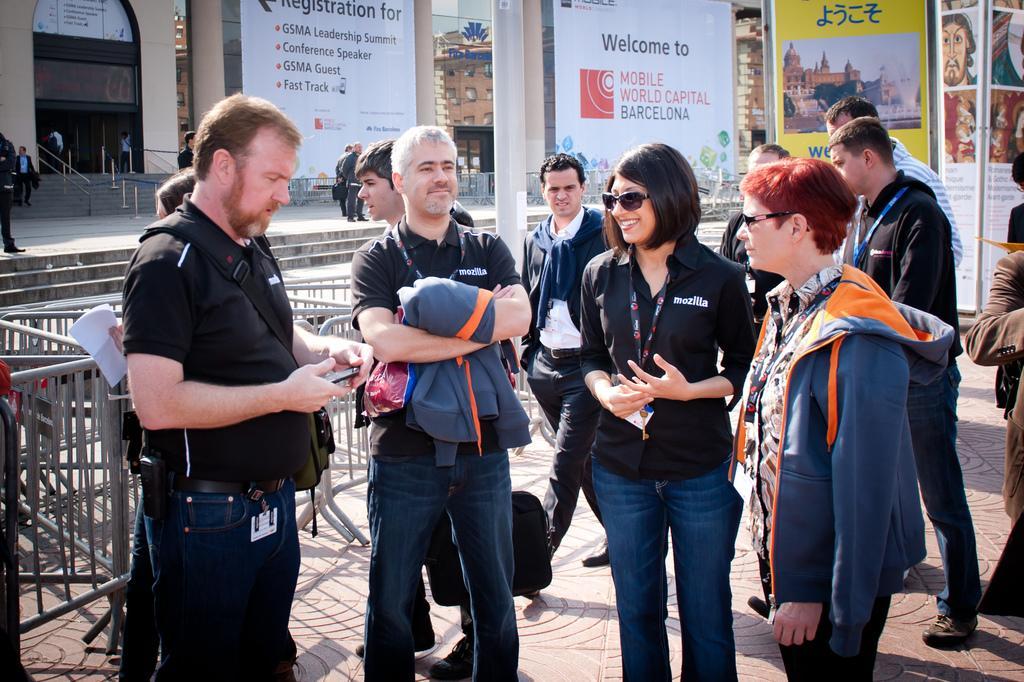How would you summarize this image in a sentence or two? In this picture we can see a few people holding objects in their hands and standing on a path. We can see a person walking on a path. There are a few barricades visible on the left side. We can see some posters, rods, ropes, people and buildings in the background. 